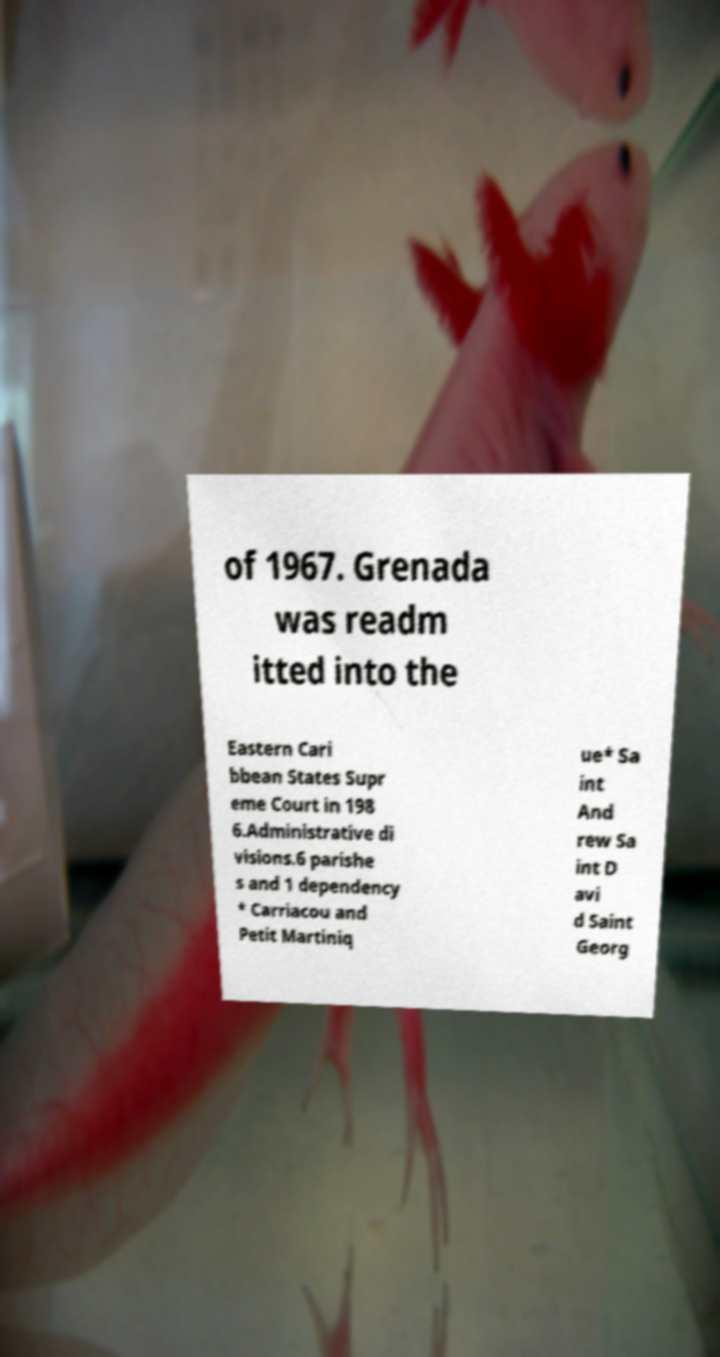For documentation purposes, I need the text within this image transcribed. Could you provide that? of 1967. Grenada was readm itted into the Eastern Cari bbean States Supr eme Court in 198 6.Administrative di visions.6 parishe s and 1 dependency * Carriacou and Petit Martiniq ue* Sa int And rew Sa int D avi d Saint Georg 